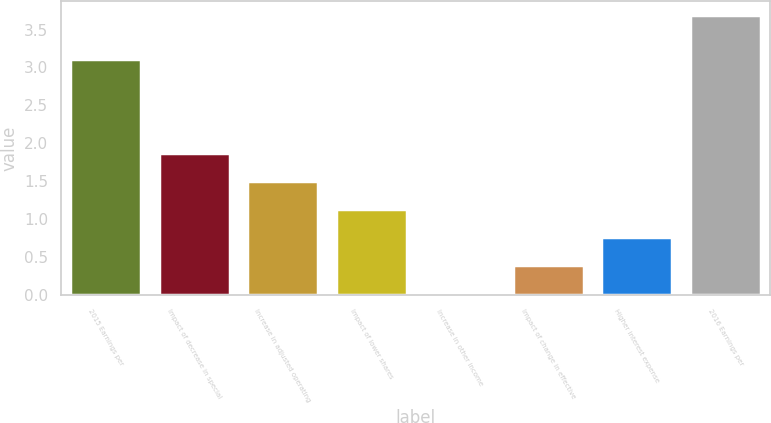<chart> <loc_0><loc_0><loc_500><loc_500><bar_chart><fcel>2015 Earnings per<fcel>Impact of decrease in special<fcel>Increase in adjusted operating<fcel>Impact of lower shares<fcel>Increase in other income<fcel>Impact of change in effective<fcel>Higher interest expense<fcel>2016 Earnings per<nl><fcel>3.11<fcel>1.87<fcel>1.5<fcel>1.13<fcel>0.02<fcel>0.39<fcel>0.76<fcel>3.69<nl></chart> 